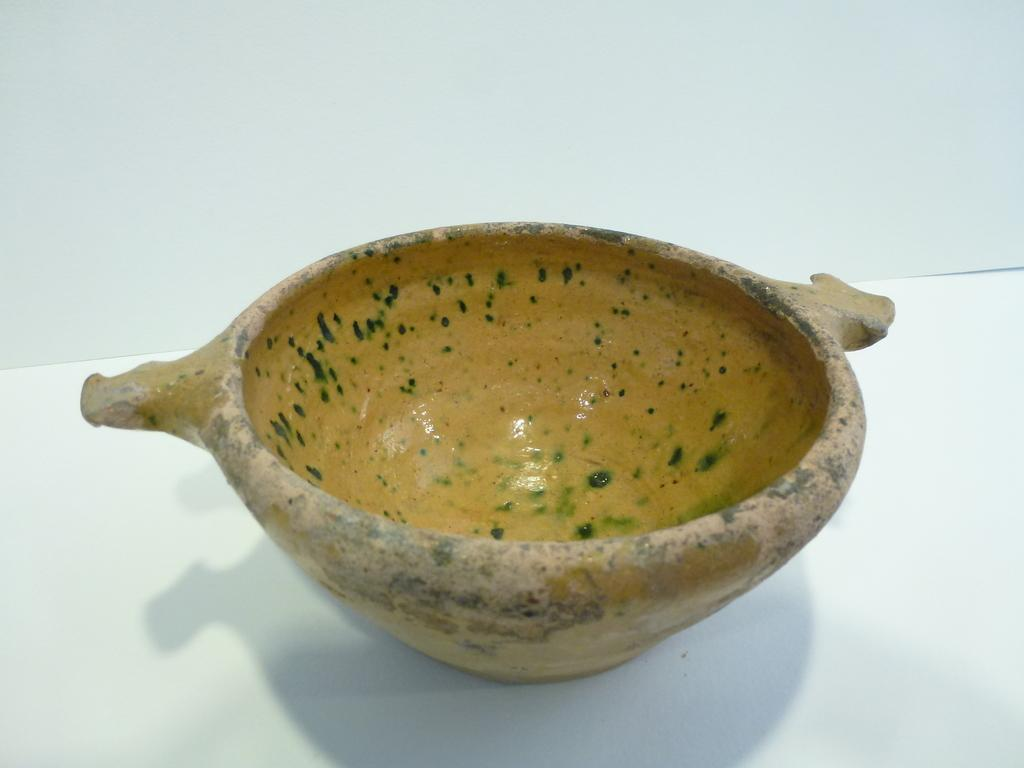What is present in the image? There is a bowl in the image. What type of substance is the dog drinking from the bowl in the image? There is no dog or drinkable substance present in the image; it only features a bowl. 